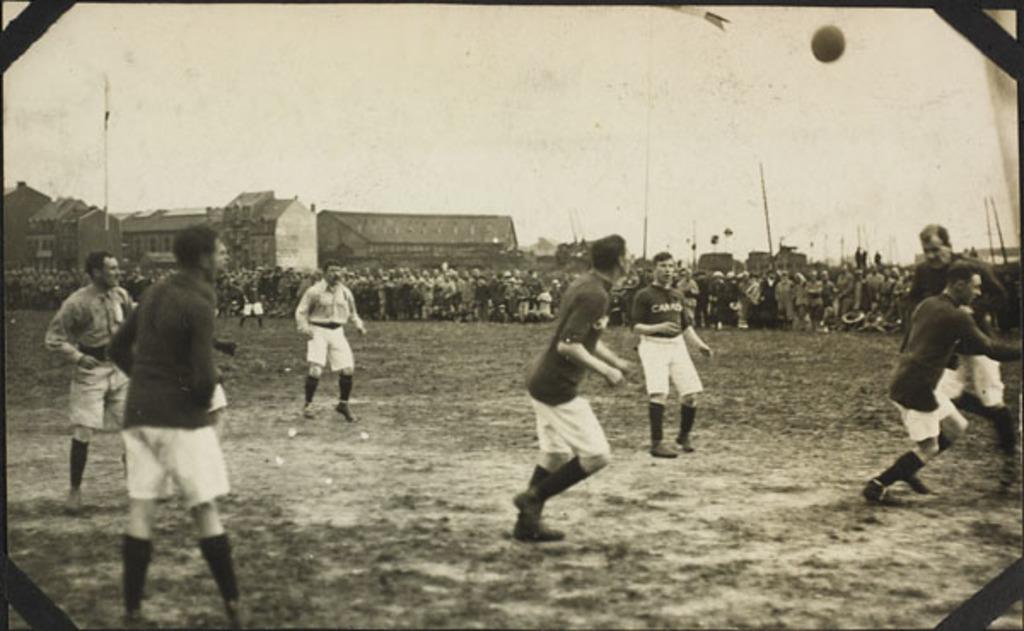Describe this image in one or two sentences. This is a black and white image. In this image, we can see a group of people are playing a game. In the background, we can also see a group of people, building, pole. At the top, we can see a wall and a sky, at the bottom, we can see a land with some stones. 